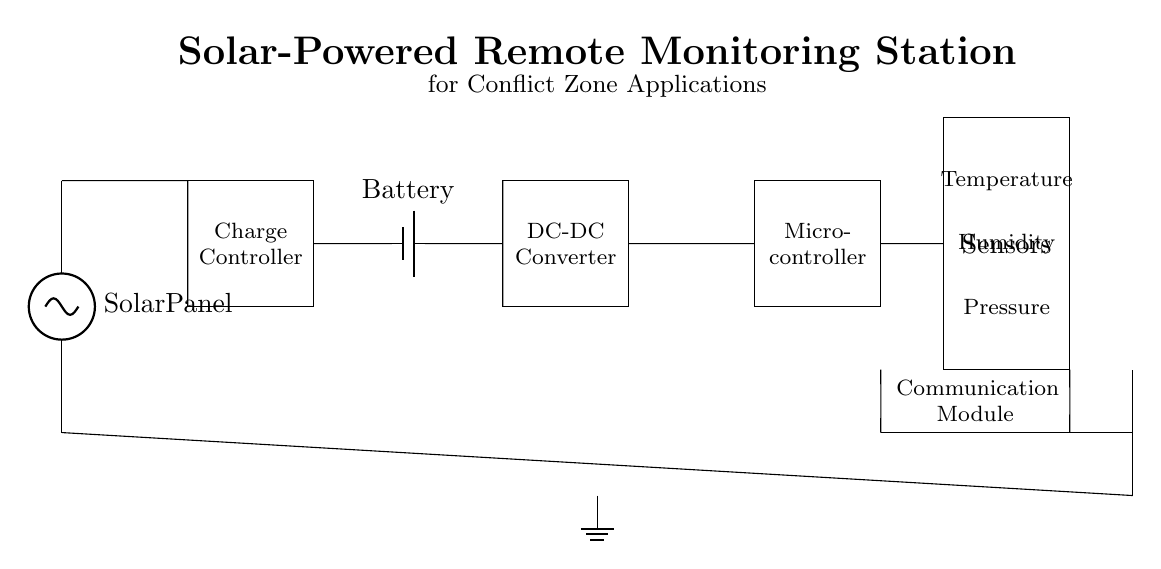What is the main power source in this circuit? The main power source is the solar panel located at the top of the circuit, indicated by its label. It provides the necessary energy to the entire system.
Answer: Solar panel What component is responsible for voltage regulation? The charge controller is the component shown in the circuit diagram that regulates the voltage coming from the solar panel to ensure optimal charging of the battery.
Answer: Charge controller How many sensors are included in the circuit? There are three sensors depicted in the circuit which are temperature, humidity, and pressure sensors, as labeled inside the sensor block.
Answer: Three What function does the communication module serve? The communication module is designed to enable data transmission from the monitoring station to a remote receiver, as indicated in its labeled section.
Answer: Data transmission What type of energy storage component is present? The circuit contains a battery, which is marked and functions as the energy storage unit for supplying power when the solar panel isn't generating electricity.
Answer: Battery Which component converts DC voltage to a different level? The DC-DC converter is present in the circuit and is responsible for adjusting the direct current voltage level as needed for other components to function properly.
Answer: DC-DC converter 